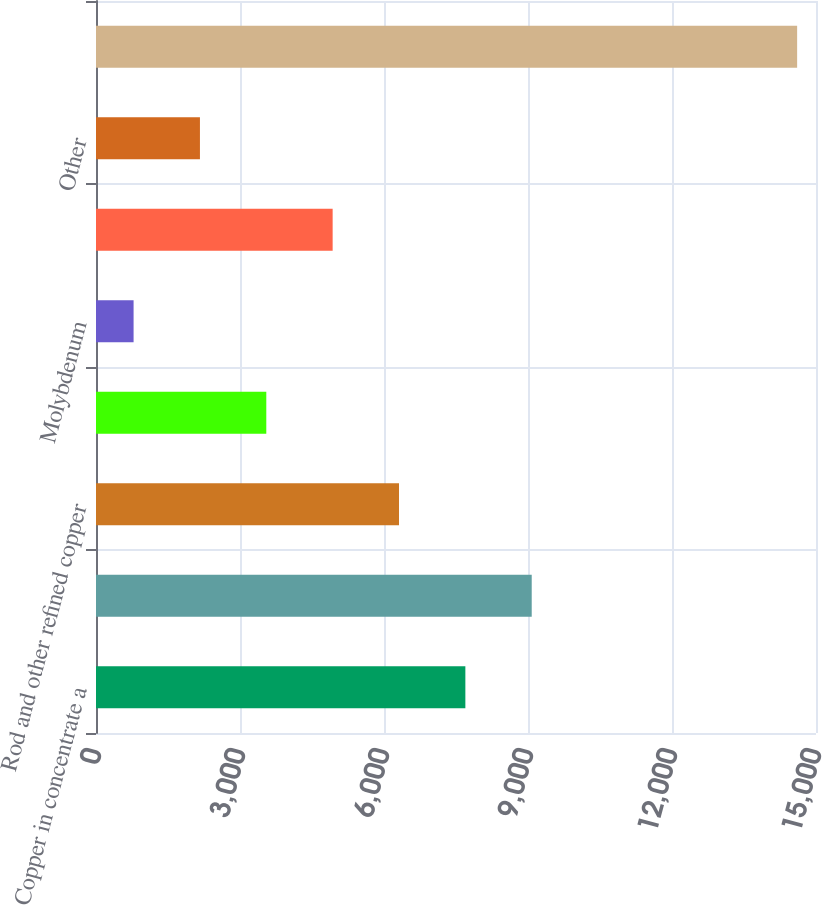Convert chart to OTSL. <chart><loc_0><loc_0><loc_500><loc_500><bar_chart><fcel>Copper in concentrate a<fcel>Copper cathode<fcel>Rod and other refined copper<fcel>Gold<fcel>Molybdenum<fcel>Oil<fcel>Other<fcel>Total<nl><fcel>7695<fcel>9077.4<fcel>6312.6<fcel>3547.8<fcel>783<fcel>4930.2<fcel>2165.4<fcel>14607<nl></chart> 